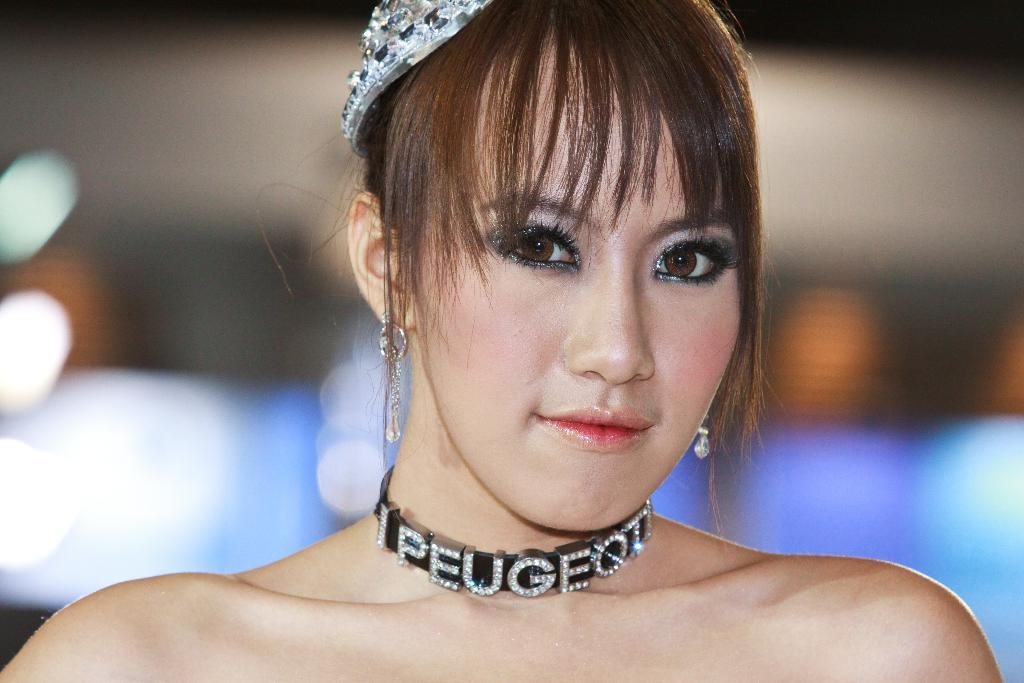Who is present in the image? There is a woman in the image. What is the woman wearing around her neck? The woman is wearing a neck piece. What type of headwear is the woman wearing? The woman is wearing a crown. Can you describe the background of the image? The background of the image is blurred. What can be seen in the background of the image? There are lights in the background of the image. What type of desk is visible in the image? There is no desk present in the image. What is the woman fighting with in the image? There is no fight or any indication of conflict in the image. 